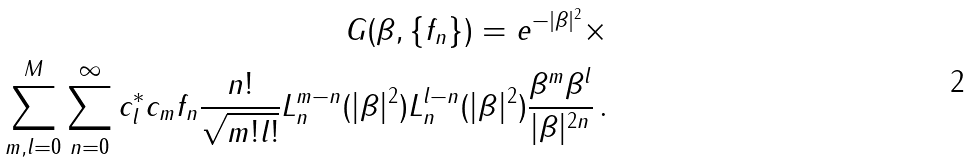Convert formula to latex. <formula><loc_0><loc_0><loc_500><loc_500>G ( \beta , \{ f _ { n } \} ) = e ^ { - | \beta | ^ { 2 } } \times \\ \sum _ { m , l = 0 } ^ { M } \sum _ { n = 0 } ^ { \infty } c _ { l } ^ { * } c _ { m } f _ { n } \frac { n ! } { \sqrt { m ! l ! } } L _ { n } ^ { m - n } ( | \beta | ^ { 2 } ) L _ { n } ^ { l - n } ( | \beta | ^ { 2 } ) \frac { \beta ^ { m } \beta ^ { l } } { | \beta | ^ { 2 n } } \, .</formula> 